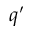<formula> <loc_0><loc_0><loc_500><loc_500>q ^ { \prime }</formula> 